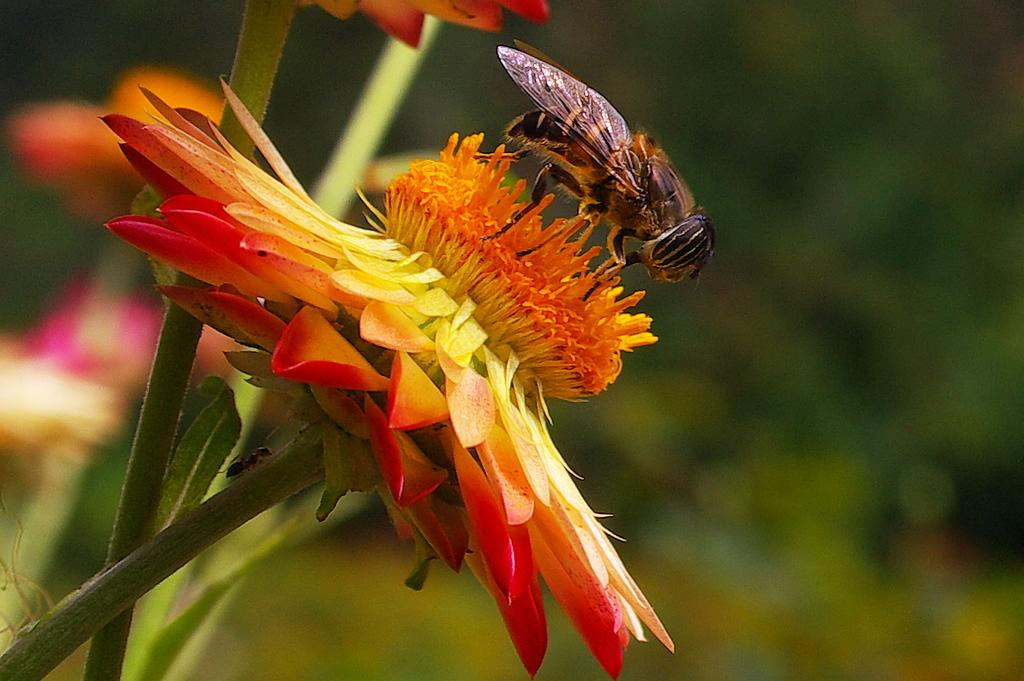What is present in the image? There is a flower in the image. What is on the flower? There is an insect on the flower. What color is the flower? The flower is in orange color. How many planes can be seen flying over the flower in the image? There are no planes visible in the image; it only features a flower with an insect on it. What type of interest does the insect have in the flower? The image does not provide information about the insect's interest in the flower. 